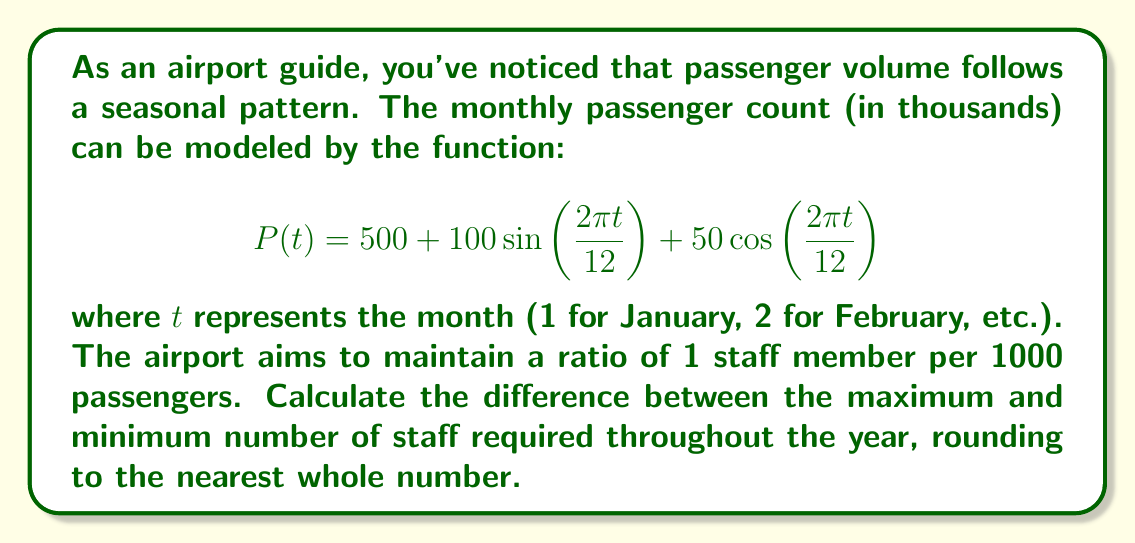Give your solution to this math problem. To solve this problem, we need to follow these steps:

1) Find the maximum and minimum values of $P(t)$.
2) Convert these passenger counts to staff numbers.
3) Calculate the difference between max and min staff numbers.

Step 1: Finding max and min of $P(t)$

The function $P(t)$ is periodic with period 12. To find its extrema, we can differentiate:

$$P'(t) = 100\cdot\frac{2\pi}{12}\cos\left(\frac{2\pi t}{12}\right) - 50\cdot\frac{2\pi}{12}\sin\left(\frac{2\pi t}{12}\right)$$

Setting $P'(t) = 0$:

$$\frac{2\pi}{12}\left(100\cos\left(\frac{2\pi t}{12}\right) - 50\sin\left(\frac{2\pi t}{12}\right)\right) = 0$$

This occurs when $\tan\left(\frac{2\pi t}{12}\right) = 2$, or when $t \approx 2.03$ and $t \approx 8.03$ (modulo 12).

Evaluating $P(t)$ at these points:

$$P(2.03) \approx 610.8$$
$$P(8.03) \approx 389.2$$

Step 2: Converting to staff numbers

Max staff = $610.8 / 1000 = 0.6108$ staff per passenger
Min staff = $389.2 / 1000 = 0.3892$ staff per passenger

Step 3: Calculating the difference

Difference = $0.6108 - 0.3892 = 0.2216$

Rounding to the nearest whole number: 0.2216 * 1000 ≈ 222
Answer: 222 staff members 